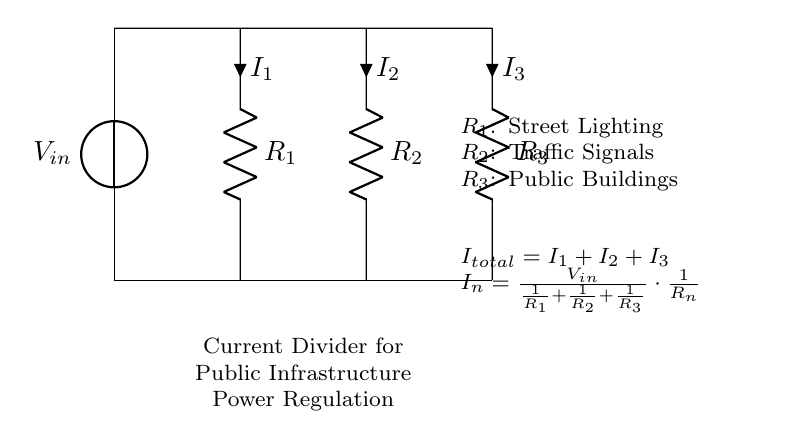What is the input voltage of the circuit? The input voltage, denoted as V_in, is the voltage source connected at the top of the circuit.
Answer: V_in What type of components are used in this circuit? The circuit consists of resistors labeled R1, R2, and R3, and a voltage source labeled V_in, indicating that it is primarily composed of resistive elements.
Answer: Resistors What is the total current in the circuit? The total current, I_total, is the sum of the individual currents I1, I2, and I3 flowing through each resistor, as indicated by the equation provided in the circuit.
Answer: I1 + I2 + I3 What is the role of R1 in the current divider? R1 is a resistor, specifically connected to street lighting, and it plays a role in dividing the total current based on its resistance value in accordance with Ohm's Law.
Answer: Street Lighting How does the current divide among the resistors? The current divides according to the resistances of R1, R2, and R3, with the relationship given by the current divider formula, which states that the current through each resistor is inversely proportional to its resistance.
Answer: Inversely proportional to resistance What happens to the current if R1 is removed? If R1 is removed, the total resistance of the circuit decreases, which would result in an increase in total current from the voltage source, redistributing the current among the remaining resistors.
Answer: Current increases 